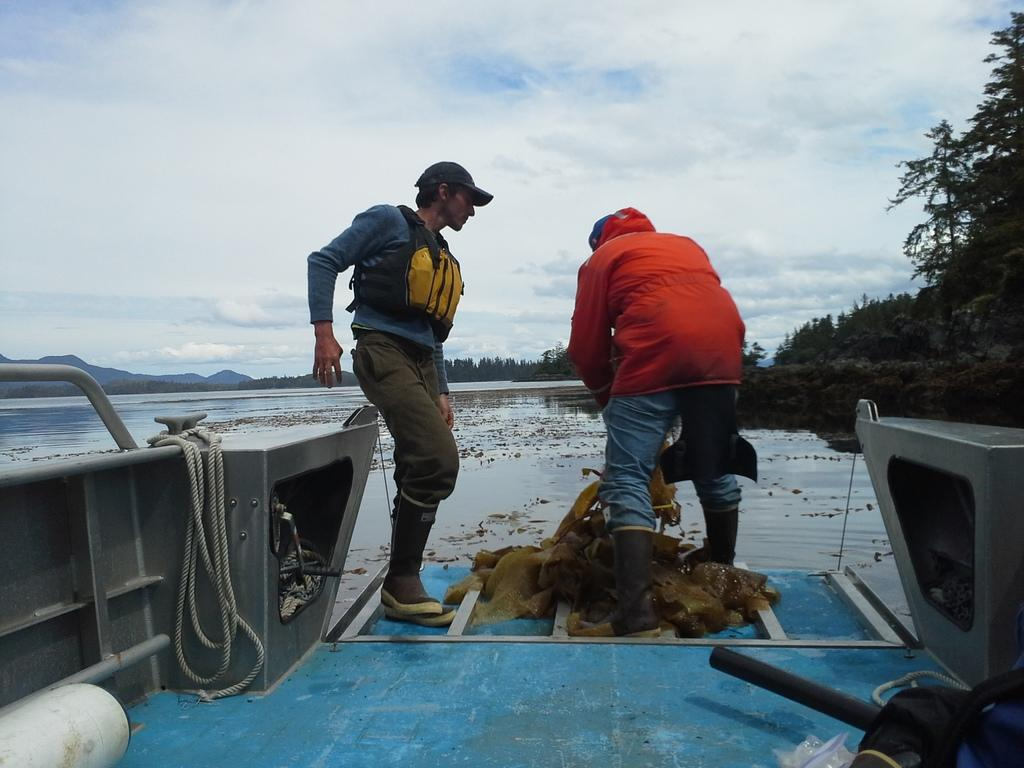What are the men in the image doing? The men in the image are standing on a boat. What are the men wearing on their heads? The men are wearing caps on their heads. What type of clothing are the men wearing? The men are wearing jackets. What can be seen in the background of the image? There are trees and hills visible in the background. What is the condition of the sky in the image? The sky is blue and cloudy. What object can be seen in the image related to the boat? There is a rope in the image. What type of donkey can be seen carrying a substance in the image? There is no donkey or substance present in the image; it features men standing on a boat. What type of spoon is being used by the men to stir the water in the image? There is no spoon present in the image, and the men are not stirring the water. 